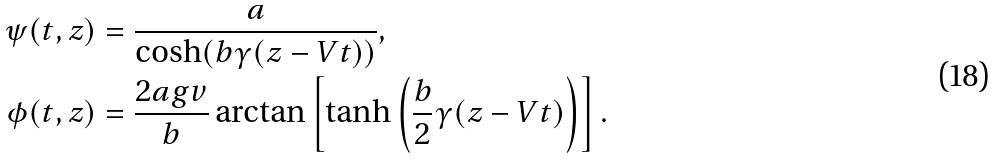Convert formula to latex. <formula><loc_0><loc_0><loc_500><loc_500>\psi ( t , z ) & = \frac { a } { \cosh ( b \gamma ( z - V t ) ) } , \\ \phi ( t , z ) & = \frac { 2 a g v } { b } \arctan \left [ \tanh \left ( \frac { b } { 2 } \gamma ( z - V t ) \right ) \right ] .</formula> 